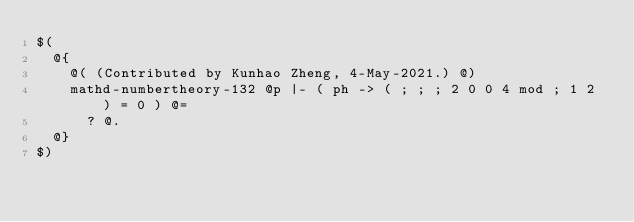<code> <loc_0><loc_0><loc_500><loc_500><_ObjectiveC_>$(
  @{
    @( (Contributed by Kunhao Zheng, 4-May-2021.) @)
    mathd-numbertheory-132 @p |- ( ph -> ( ; ; ; 2 0 0 4 mod ; 1 2 ) = 0 ) @=
      ? @.
  @}
$)
</code> 